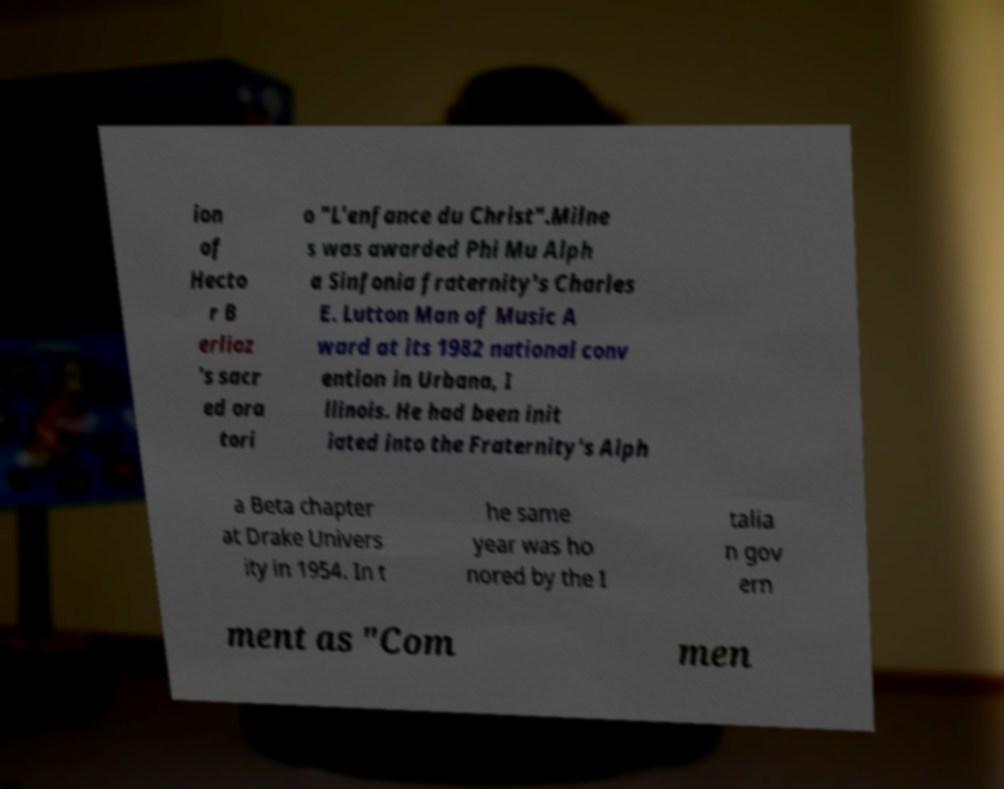Please identify and transcribe the text found in this image. ion of Hecto r B erlioz 's sacr ed ora tori o "L'enfance du Christ".Milne s was awarded Phi Mu Alph a Sinfonia fraternity's Charles E. Lutton Man of Music A ward at its 1982 national conv ention in Urbana, I llinois. He had been init iated into the Fraternity's Alph a Beta chapter at Drake Univers ity in 1954. In t he same year was ho nored by the I talia n gov ern ment as "Com men 